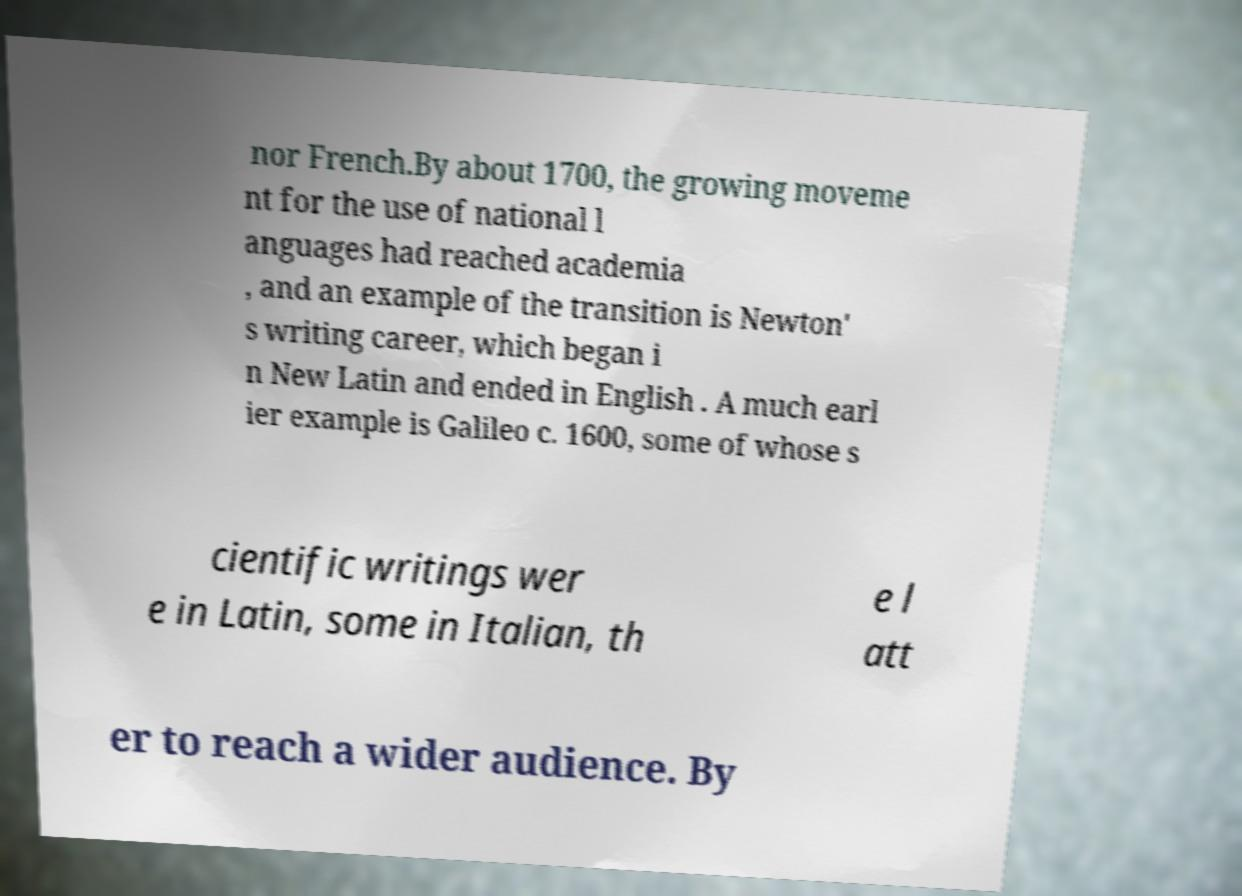I need the written content from this picture converted into text. Can you do that? nor French.By about 1700, the growing moveme nt for the use of national l anguages had reached academia , and an example of the transition is Newton' s writing career, which began i n New Latin and ended in English . A much earl ier example is Galileo c. 1600, some of whose s cientific writings wer e in Latin, some in Italian, th e l att er to reach a wider audience. By 